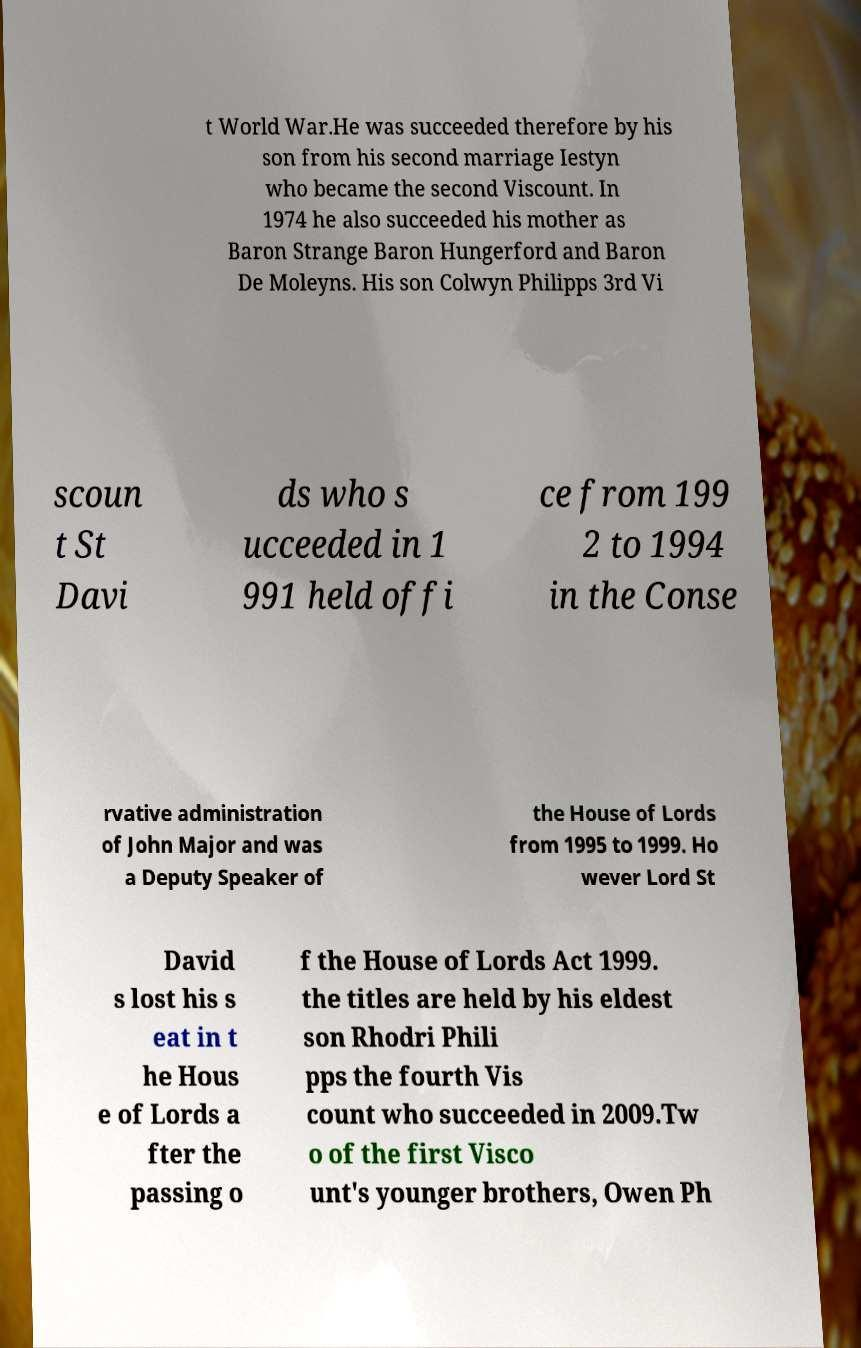Could you extract and type out the text from this image? t World War.He was succeeded therefore by his son from his second marriage Iestyn who became the second Viscount. In 1974 he also succeeded his mother as Baron Strange Baron Hungerford and Baron De Moleyns. His son Colwyn Philipps 3rd Vi scoun t St Davi ds who s ucceeded in 1 991 held offi ce from 199 2 to 1994 in the Conse rvative administration of John Major and was a Deputy Speaker of the House of Lords from 1995 to 1999. Ho wever Lord St David s lost his s eat in t he Hous e of Lords a fter the passing o f the House of Lords Act 1999. the titles are held by his eldest son Rhodri Phili pps the fourth Vis count who succeeded in 2009.Tw o of the first Visco unt's younger brothers, Owen Ph 